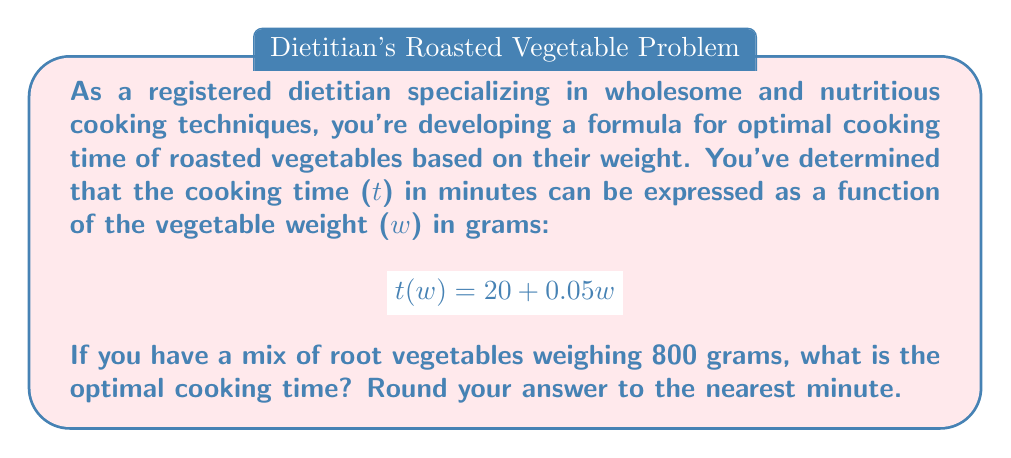Show me your answer to this math problem. To solve this problem, we need to use the given function and substitute the weight of the vegetables:

1. The function for cooking time (t) in minutes based on weight (w) in grams is:
   $$t(w) = 20 + 0.05w$$

2. We're given that the weight of the root vegetables is 800 grams, so we substitute w = 800:
   $$t(800) = 20 + 0.05(800)$$

3. Let's calculate step by step:
   $$t(800) = 20 + 40$$
   $$t(800) = 60$$

4. The result is 60 minutes. Since we're asked to round to the nearest minute, no further rounding is necessary.

This cooking time ensures that the vegetables are properly cooked, maintaining their nutritional value while achieving the desired texture and flavor.
Answer: 60 minutes 